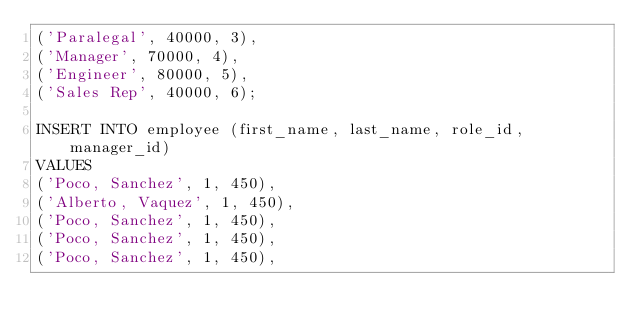Convert code to text. <code><loc_0><loc_0><loc_500><loc_500><_SQL_>('Paralegal', 40000, 3),
('Manager', 70000, 4),
('Engineer', 80000, 5),
('Sales Rep', 40000, 6);

INSERT INTO employee (first_name, last_name, role_id, manager_id)
VALUES
('Poco, Sanchez', 1, 450),
('Alberto, Vaquez', 1, 450),
('Poco, Sanchez', 1, 450),
('Poco, Sanchez', 1, 450),
('Poco, Sanchez', 1, 450),</code> 